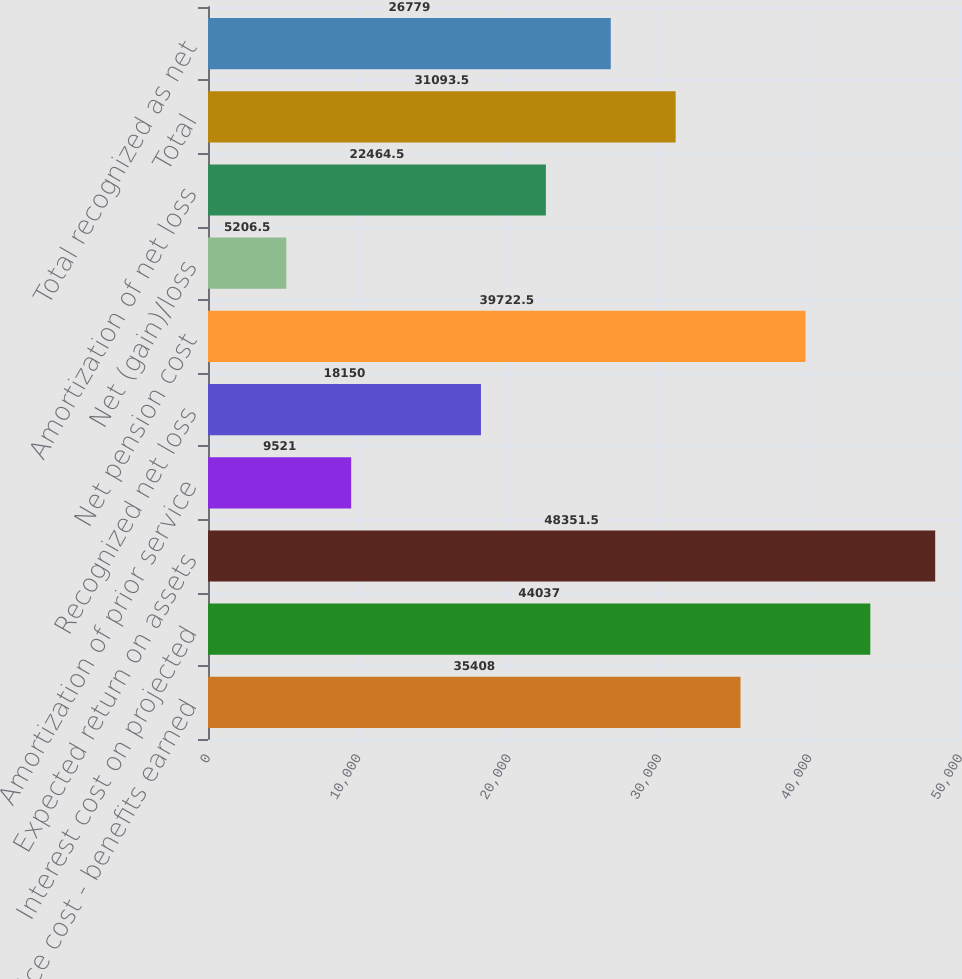Convert chart. <chart><loc_0><loc_0><loc_500><loc_500><bar_chart><fcel>Service cost - benefits earned<fcel>Interest cost on projected<fcel>Expected return on assets<fcel>Amortization of prior service<fcel>Recognized net loss<fcel>Net pension cost<fcel>Net (gain)/loss<fcel>Amortization of net loss<fcel>Total<fcel>Total recognized as net<nl><fcel>35408<fcel>44037<fcel>48351.5<fcel>9521<fcel>18150<fcel>39722.5<fcel>5206.5<fcel>22464.5<fcel>31093.5<fcel>26779<nl></chart> 